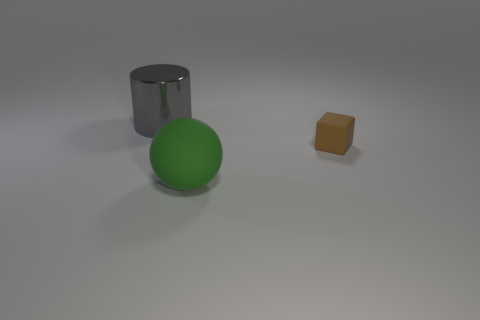There is a thing that is on the right side of the large thing that is to the right of the metal object; what is its material?
Keep it short and to the point. Rubber. Are any green metallic cubes visible?
Give a very brief answer. No. There is a thing that is on the right side of the large thing that is in front of the brown rubber block; what size is it?
Offer a very short reply. Small. Are there more small rubber blocks that are behind the cube than big shiny things that are to the right of the large ball?
Give a very brief answer. No. What number of cylinders are either small rubber objects or big gray objects?
Provide a succinct answer. 1. Are there any other things that have the same size as the brown block?
Offer a very short reply. No. There is a rubber object that is on the left side of the tiny thing; is its shape the same as the brown matte thing?
Ensure brevity in your answer.  No. What color is the small rubber block?
Give a very brief answer. Brown. What number of other matte things have the same shape as the tiny rubber thing?
Your answer should be compact. 0. What number of things are small brown rubber blocks or objects that are to the left of the brown rubber thing?
Your response must be concise. 3. 